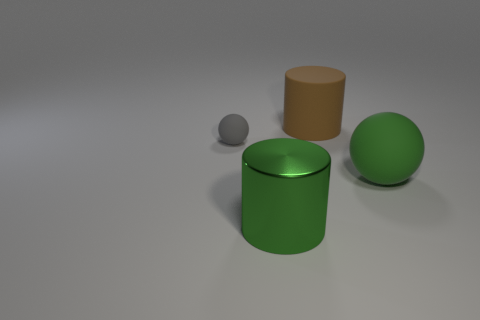Do the metal thing and the big ball have the same color? yes 